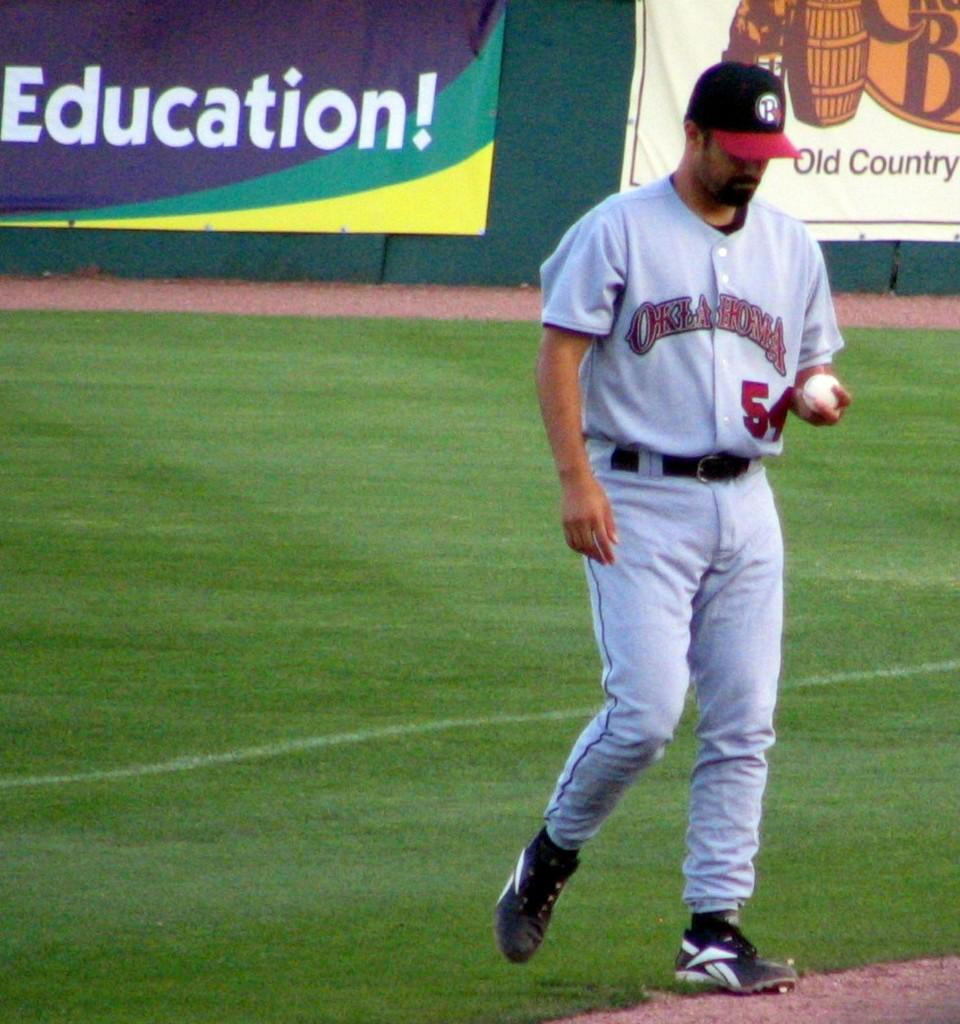<image>
Relay a brief, clear account of the picture shown. A man in an Oklahoma baseball uniform holds a baseball. 